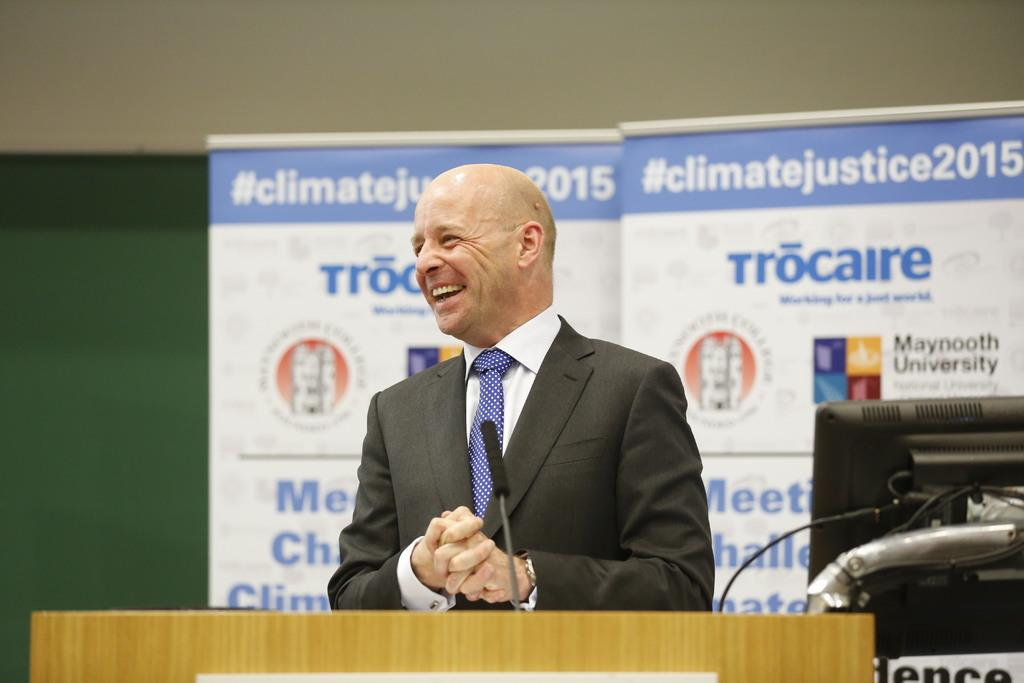What is the man in the image doing? The man is standing and smiling in the image. What is located in front of the man? There is a microphone above a podium in front of the man. What electronic device can be seen in the image? There is a monitor visible in the image. What can be seen in the background of the image? There are banners and a wall visible in the background of the image. What type of corn is growing on the wall in the image? There is no corn visible in the image; it only shows a man, a microphone, a podium, a monitor, banners, and a wall. 